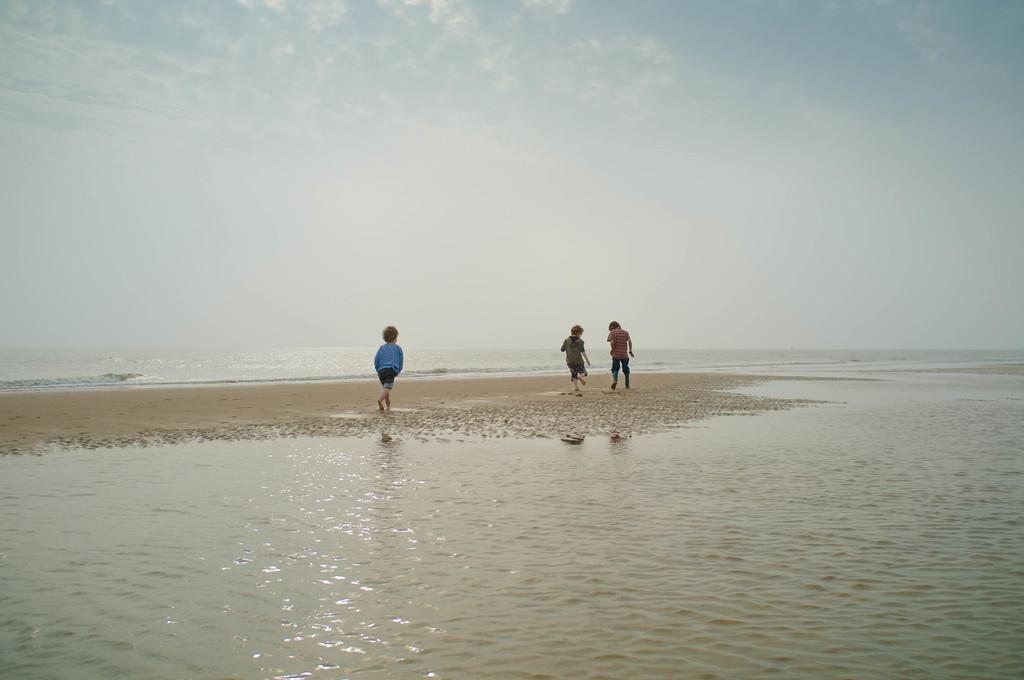How many people are in the image? There are three persons in the image. What are the persons doing in the image? The persons are running. Where is the running taking place? The running is taking place near the beach. What can be seen at the bottom of the image? There is water visible at the bottom of the image. What is the condition of the sky in the background? There are clouds in the sky in the background. What type of terrain is visible in the middle of the image? There is sand in the middle of the image. What type of tooth is visible in the image? There is no tooth present in the image. What action is the grandfather performing in the image? There is no grandfather present in the image, so it is not possible to answer that question. 